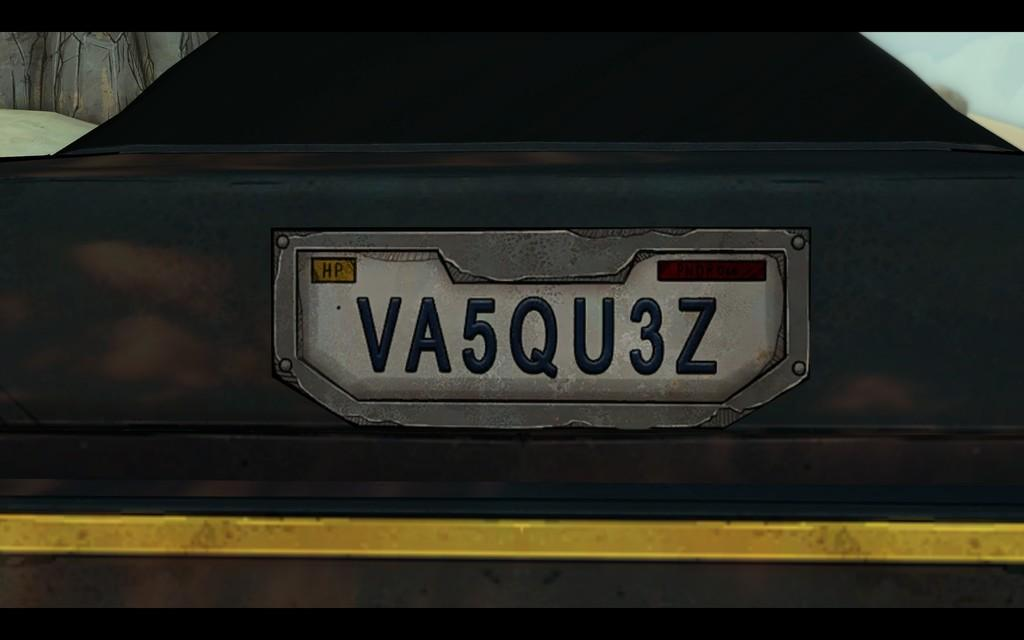What is the main subject in the front of the image? There is an object in the front of the image. Can you describe the color of the object? The object is black in color. What is written on the object? There is text and numbers written on the object. What can be seen in the background of the image? There is a wall in the background of the image. How does the family make their decision in the image? There is no family present in the image, nor is there any indication of a decision being made. 